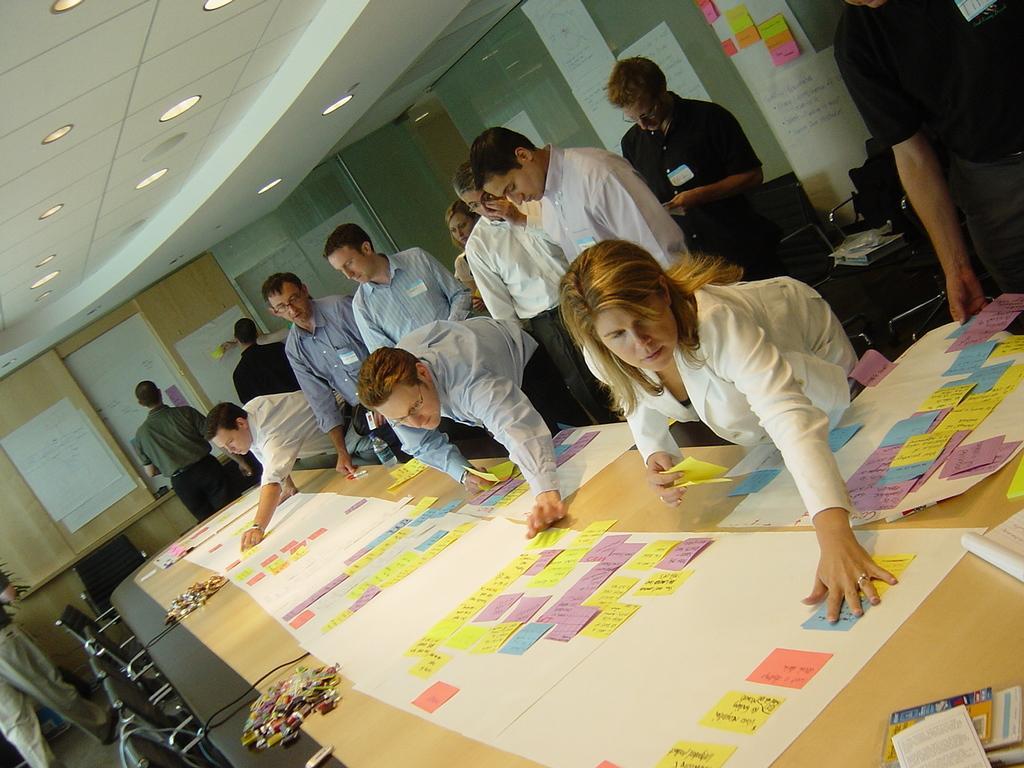Please provide a concise description of this image. In this image there are a group of people who are standing, and in front of them there is one table and on the table there are some charts and papers and also we could see some chairs. In the background there are some boards and glass windows, on the boards there are some charts and papers. At the top there is ceiling and some lights. 